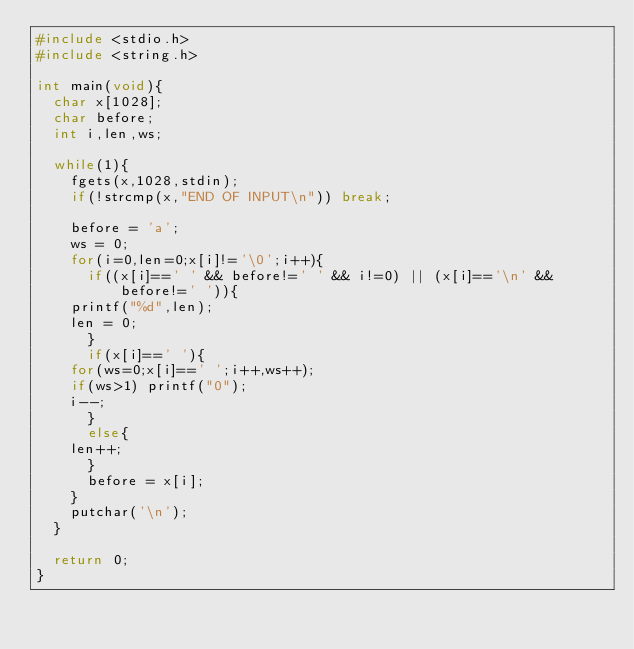<code> <loc_0><loc_0><loc_500><loc_500><_C_>#include <stdio.h>
#include <string.h>

int main(void){
  char x[1028];
  char before;
  int i,len,ws;

  while(1){
    fgets(x,1028,stdin);
    if(!strcmp(x,"END OF INPUT\n")) break;

    before = 'a';
    ws = 0;
    for(i=0,len=0;x[i]!='\0';i++){
      if((x[i]==' ' && before!=' ' && i!=0) || (x[i]=='\n' && before!=' ')){
	printf("%d",len);
	len = 0;
      }
      if(x[i]==' '){
	for(ws=0;x[i]==' ';i++,ws++);
	if(ws>1) printf("0");
	i--;
      }
      else{
	len++;
      }
      before = x[i];
    }
    putchar('\n');
  }

  return 0;
}</code> 